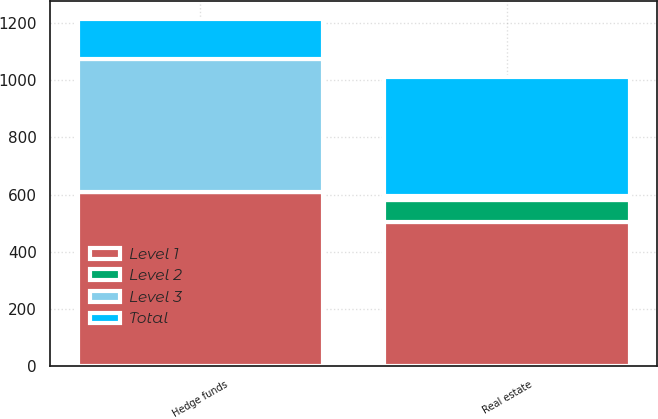Convert chart to OTSL. <chart><loc_0><loc_0><loc_500><loc_500><stacked_bar_chart><ecel><fcel>Real estate<fcel>Hedge funds<nl><fcel>Level 1<fcel>505<fcel>608<nl><fcel>Level 2<fcel>75<fcel>3<nl><fcel>Level 3<fcel>14<fcel>462<nl><fcel>Total<fcel>416<fcel>143<nl></chart> 